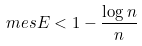<formula> <loc_0><loc_0><loc_500><loc_500>m e s E < 1 - \frac { \log n } { n }</formula> 